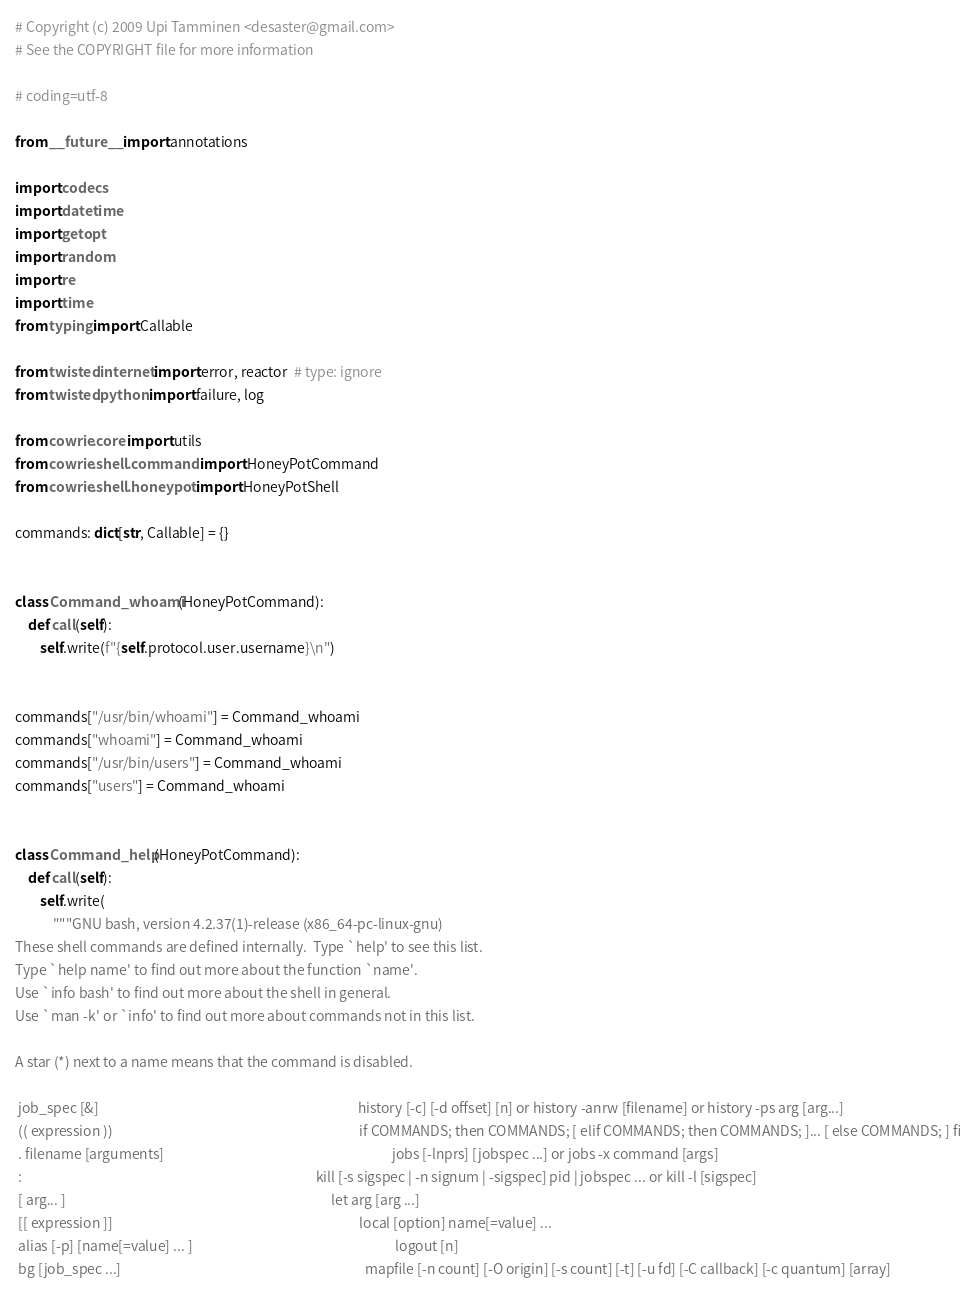Convert code to text. <code><loc_0><loc_0><loc_500><loc_500><_Python_># Copyright (c) 2009 Upi Tamminen <desaster@gmail.com>
# See the COPYRIGHT file for more information

# coding=utf-8

from __future__ import annotations

import codecs
import datetime
import getopt
import random
import re
import time
from typing import Callable

from twisted.internet import error, reactor  # type: ignore
from twisted.python import failure, log

from cowrie.core import utils
from cowrie.shell.command import HoneyPotCommand
from cowrie.shell.honeypot import HoneyPotShell

commands: dict[str, Callable] = {}


class Command_whoami(HoneyPotCommand):
    def call(self):
        self.write(f"{self.protocol.user.username}\n")


commands["/usr/bin/whoami"] = Command_whoami
commands["whoami"] = Command_whoami
commands["/usr/bin/users"] = Command_whoami
commands["users"] = Command_whoami


class Command_help(HoneyPotCommand):
    def call(self):
        self.write(
            """GNU bash, version 4.2.37(1)-release (x86_64-pc-linux-gnu)
These shell commands are defined internally.  Type `help' to see this list.
Type `help name' to find out more about the function `name'.
Use `info bash' to find out more about the shell in general.
Use `man -k' or `info' to find out more about commands not in this list.

A star (*) next to a name means that the command is disabled.

 job_spec [&]                                                                                   history [-c] [-d offset] [n] or history -anrw [filename] or history -ps arg [arg...]
 (( expression ))                                                                               if COMMANDS; then COMMANDS; [ elif COMMANDS; then COMMANDS; ]... [ else COMMANDS; ] fi
 . filename [arguments]                                                                         jobs [-lnprs] [jobspec ...] or jobs -x command [args]
 :                                                                                              kill [-s sigspec | -n signum | -sigspec] pid | jobspec ... or kill -l [sigspec]
 [ arg... ]                                                                                     let arg [arg ...]
 [[ expression ]]                                                                               local [option] name[=value] ...
 alias [-p] [name[=value] ... ]                                                                 logout [n]
 bg [job_spec ...]                                                                              mapfile [-n count] [-O origin] [-s count] [-t] [-u fd] [-C callback] [-c quantum] [array]</code> 